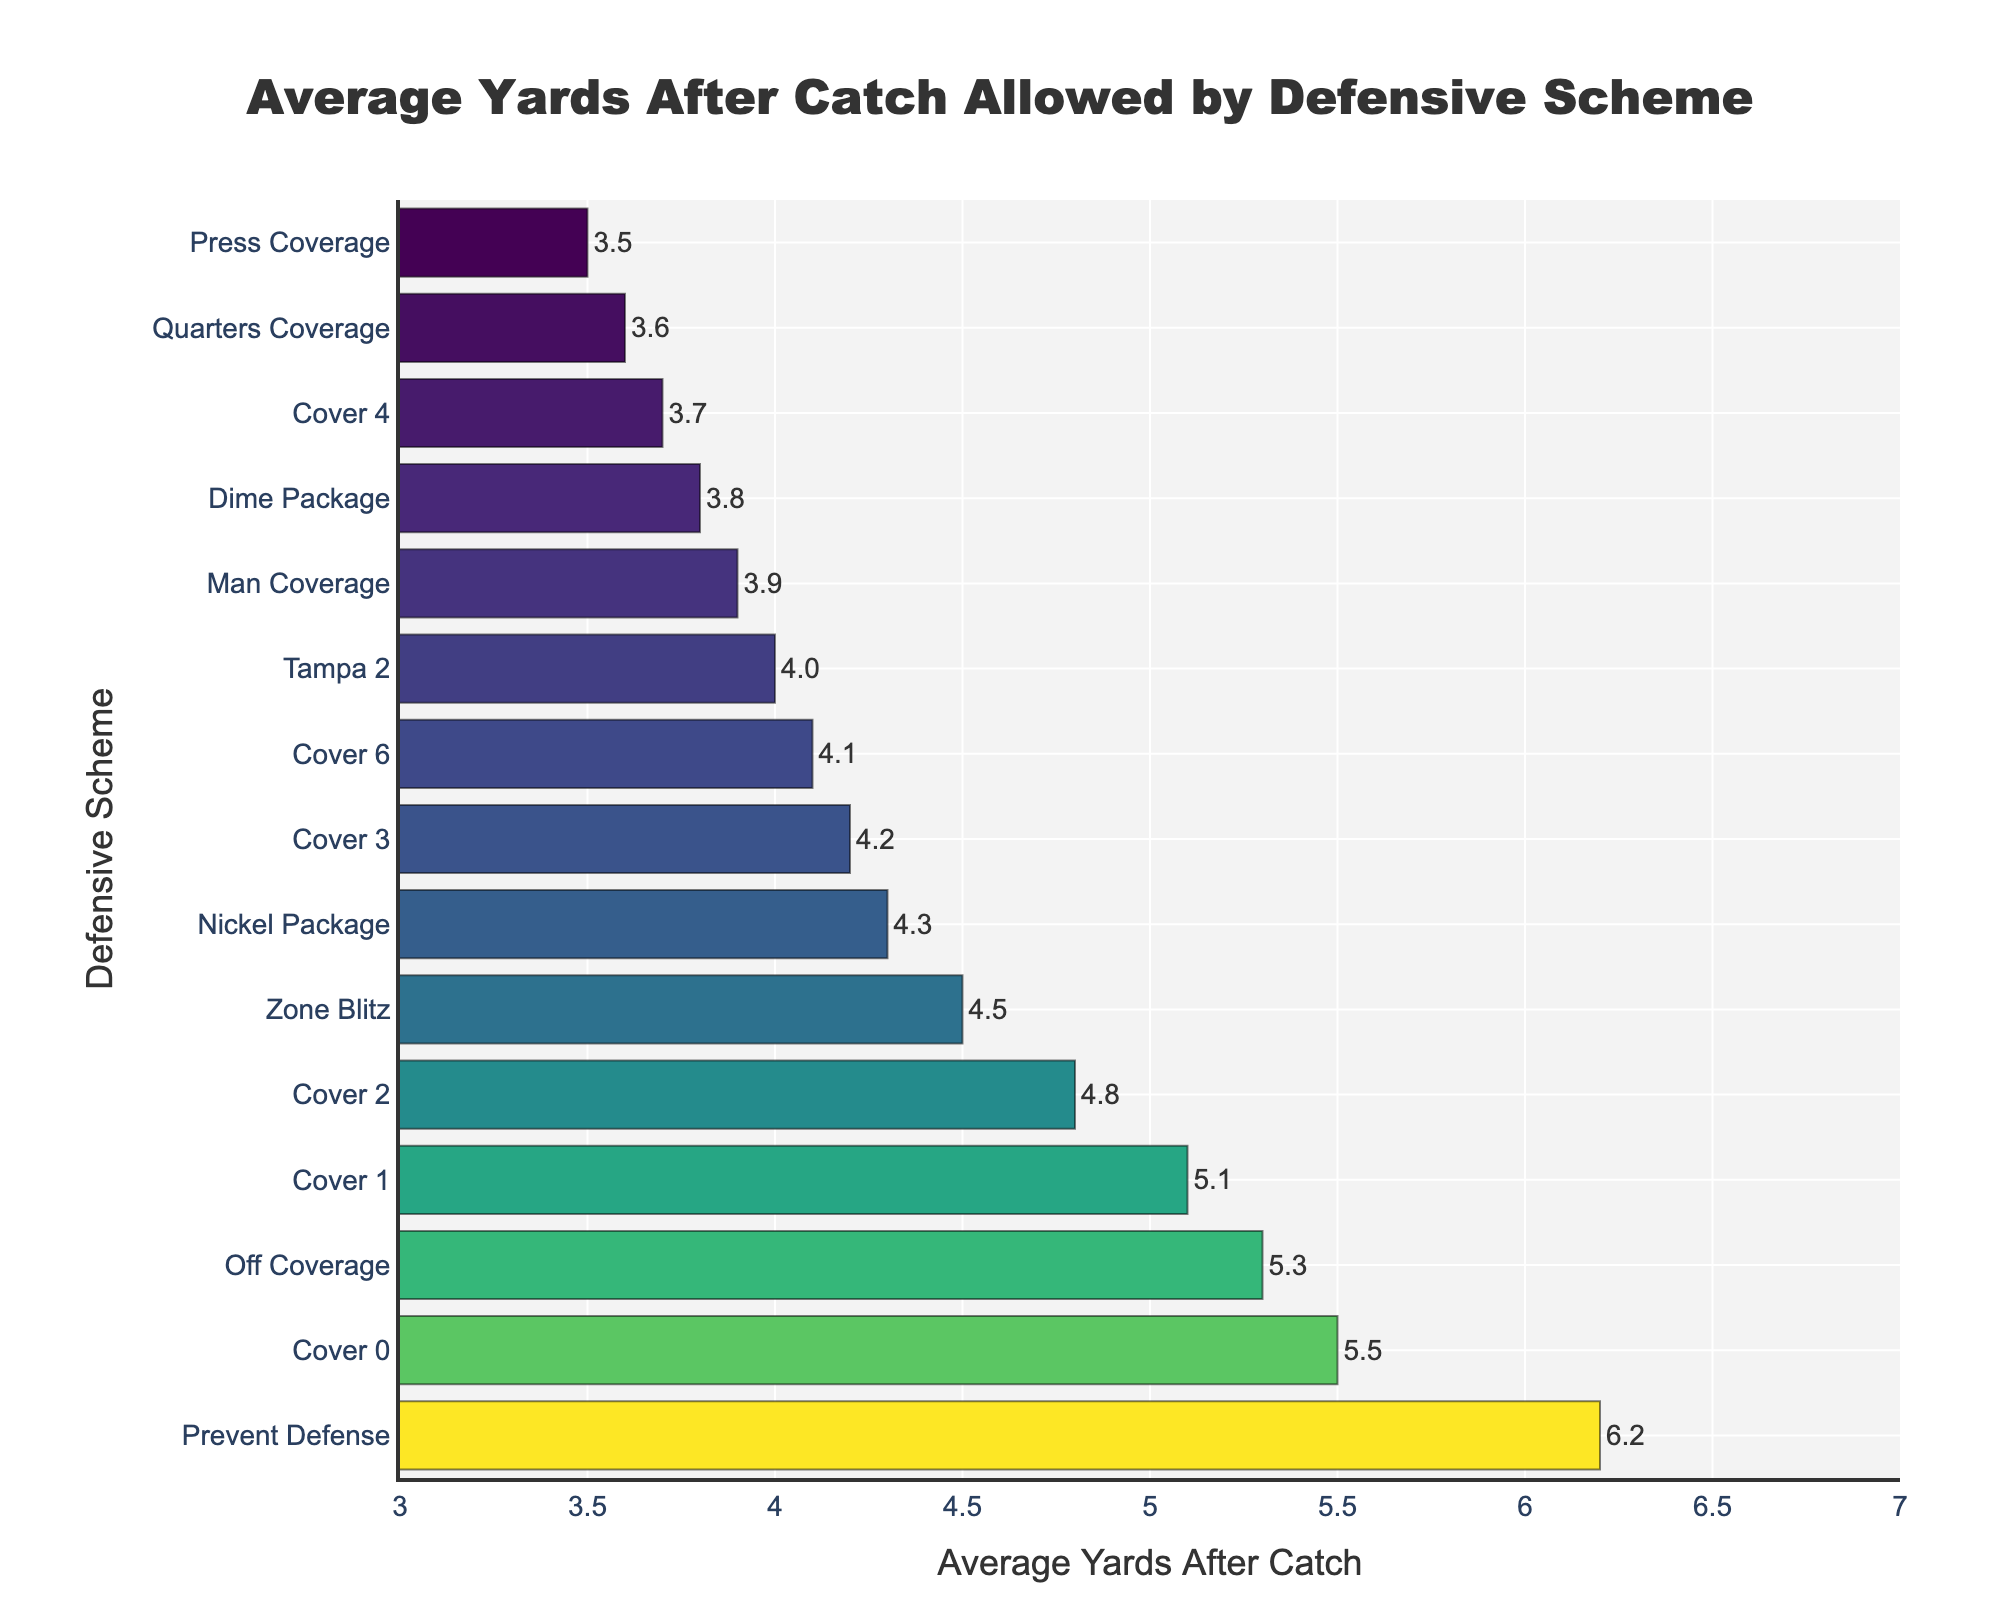Which defensive scheme allows the highest average yards after catch? The defensive scheme with the highest bar in the chart represents the highest average yards after catch allowed. "Prevent Defense" has the longest bar at 6.2 yards.
Answer: Prevent Defense Which defensive scheme allows the lowest average yards after catch? The defensive scheme with the smallest bar in the chart represents the lowest average yards after catch allowed. "Press Coverage" has the shortest bar at 3.5 yards.
Answer: Press Coverage How many defensive schemes allow more than 5 yards after catch on average? Identify bars representing more than 5 yards and count them. The schemes are "Off Coverage", "Cover 0", "Prevent Defense", and "Cover 1", a total of 4.
Answer: 4 What is the average yards after catch allowed when comparing Cover 1 and Cover 3? Compare the lengths of the bars for Cover 1 and Cover 3. Cover 1 allows 5.1 yards and Cover 3 allows 4.2 yards.
Answer: Cover 1 allows more yards after catch than Cover 3 Which schemes allow less than 4 yards after catch? Identify bars with lengths under 4 yards. They include: "Press Coverage", "Quarters Coverage", "Cover 4", and "Dime Package".
Answer: Press Coverage, Quarters Coverage, Cover 4, Dime Package What is the difference in average yards after catch allowed between the highest and lowest schemes? The highest average is 6.2 yards (Prevent Defense) and the lowest is 3.5 yards (Press Coverage). Difference is 6.2 - 3.5 = 2.7 yards.
Answer: 2.7 yards Is there any zone defense that allows less than 4 yards after catch? Examine zone defenses listed and their corresponding bar lengths. "Cover 4" allows 3.7 yards, so it is less than 4 yards.
Answer: Cover 4 How does Cover 2 compare to Nickel Package in terms of average yards after catch allowed? Compare the bar lengths for Cover 2 (4.8 yards) and Nickel Package (4.3 yards). Cover 2 allows more yards after catch than Nickel Package.
Answer: Cover 2 allows more 